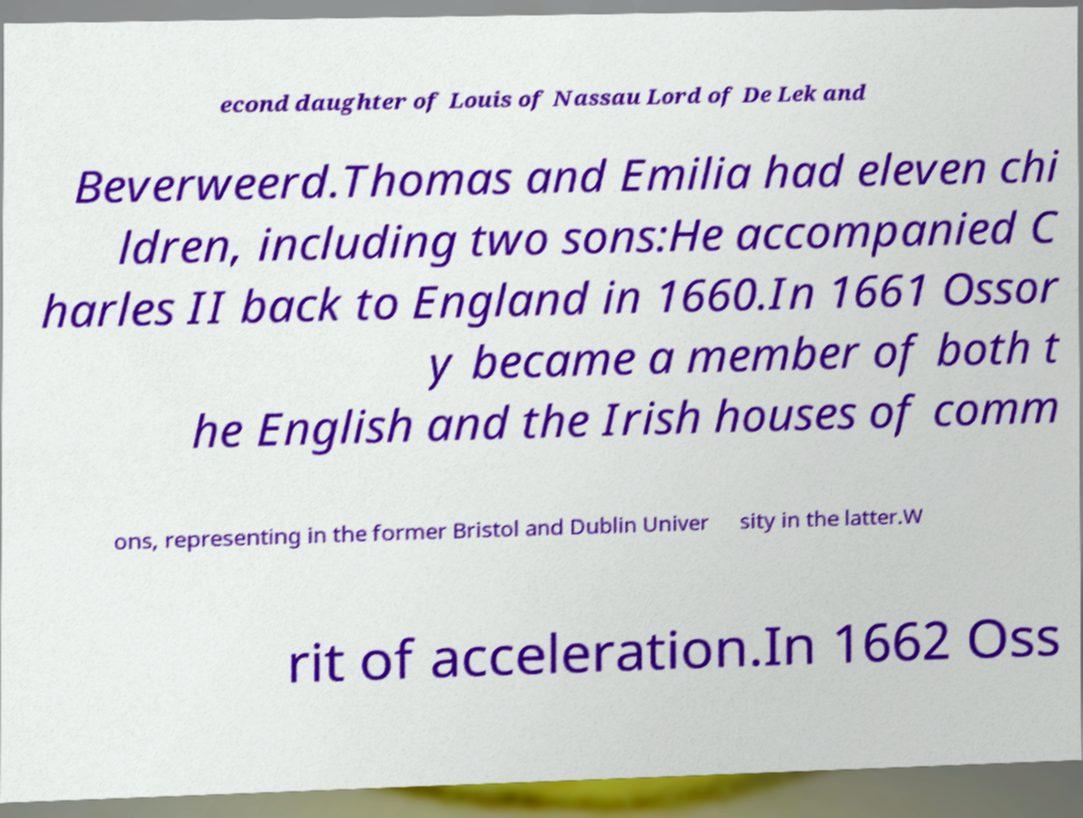I need the written content from this picture converted into text. Can you do that? econd daughter of Louis of Nassau Lord of De Lek and Beverweerd.Thomas and Emilia had eleven chi ldren, including two sons:He accompanied C harles II back to England in 1660.In 1661 Ossor y became a member of both t he English and the Irish houses of comm ons, representing in the former Bristol and Dublin Univer sity in the latter.W rit of acceleration.In 1662 Oss 